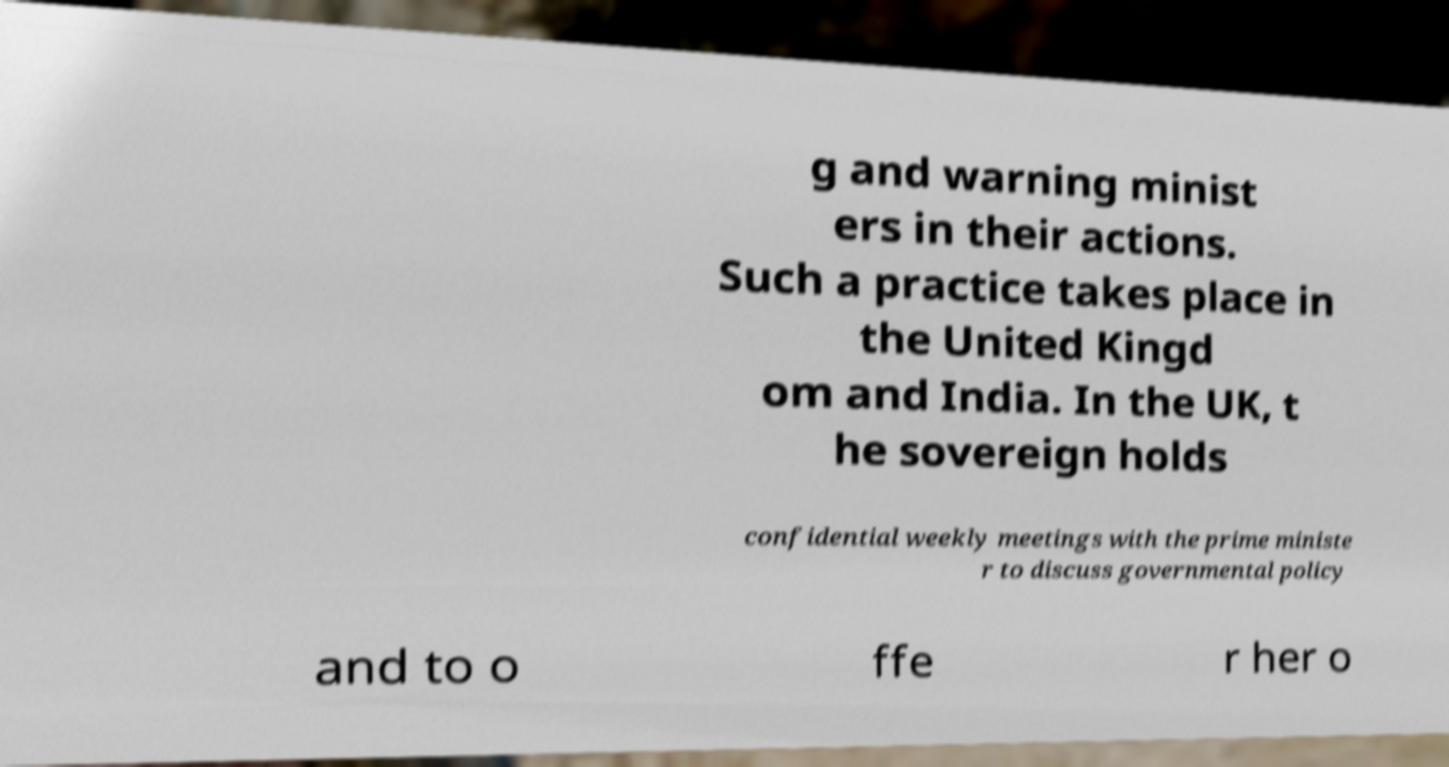I need the written content from this picture converted into text. Can you do that? g and warning minist ers in their actions. Such a practice takes place in the United Kingd om and India. In the UK, t he sovereign holds confidential weekly meetings with the prime ministe r to discuss governmental policy and to o ffe r her o 